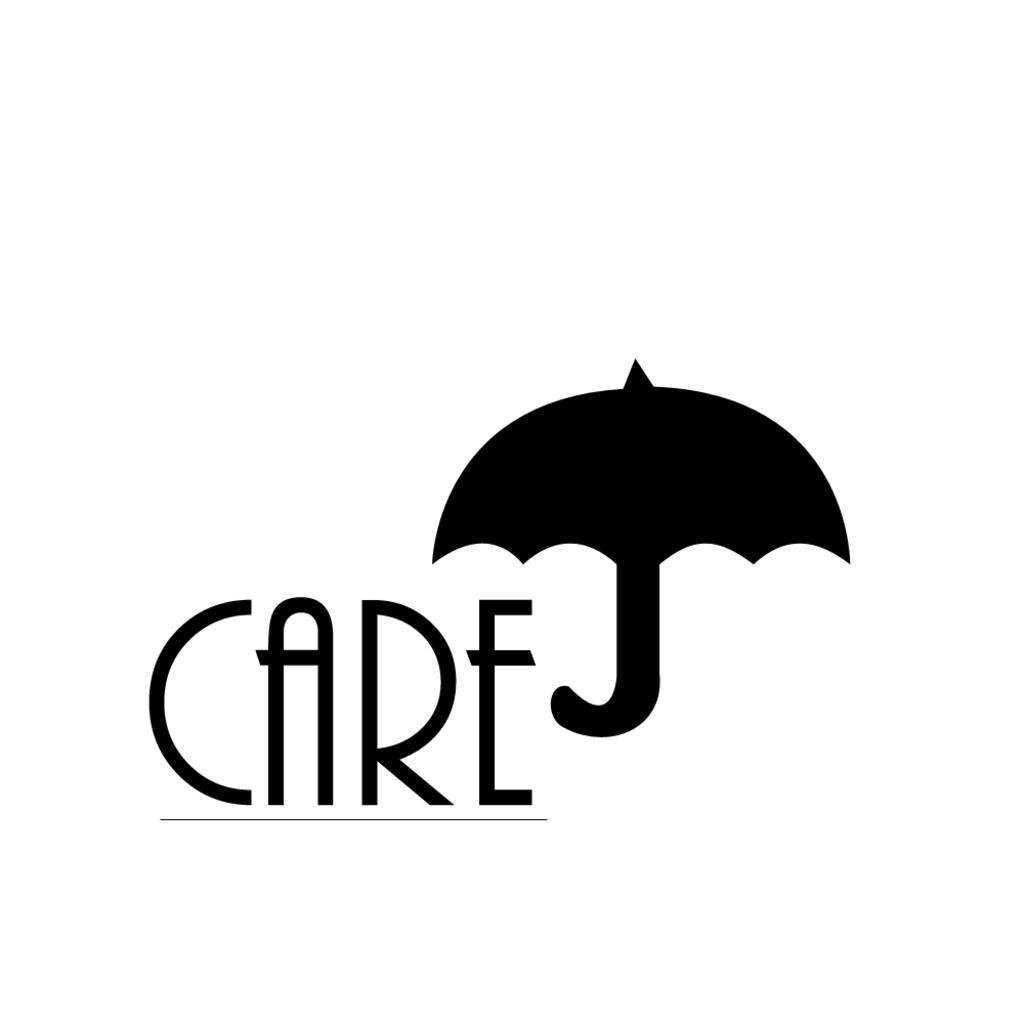Can you describe this image briefly? In this image we can see some text and a umbrella on a white color background. 